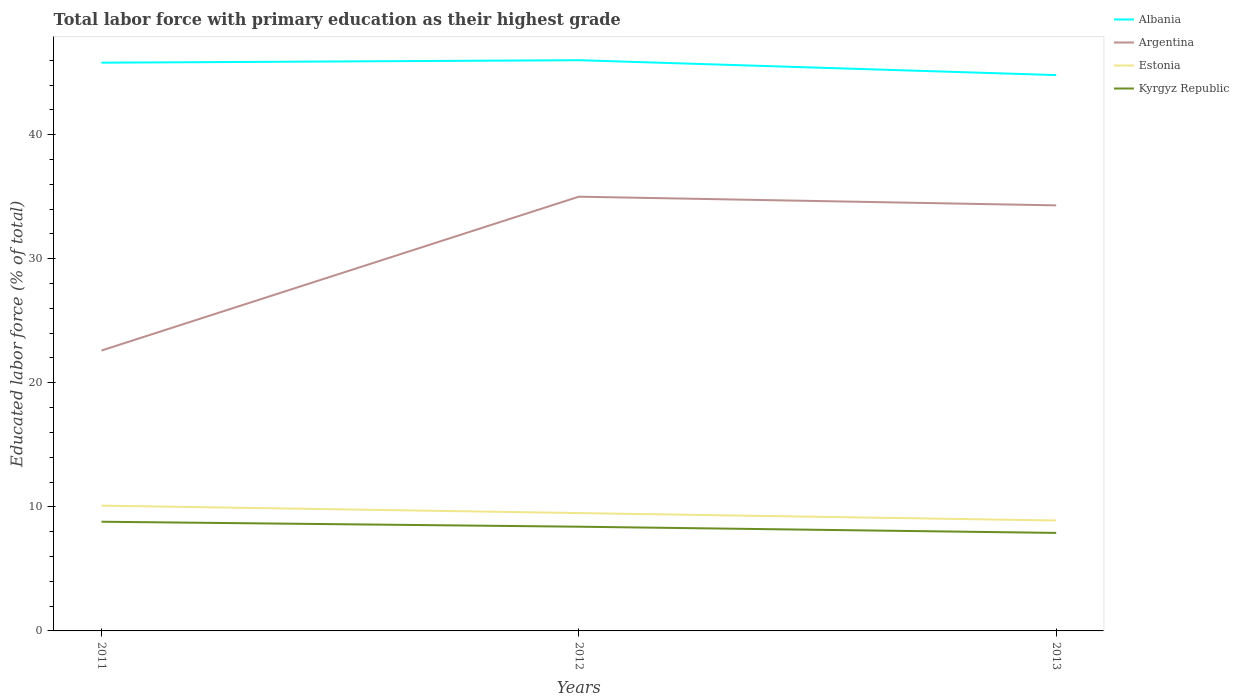Does the line corresponding to Kyrgyz Republic intersect with the line corresponding to Albania?
Keep it short and to the point. No. Is the number of lines equal to the number of legend labels?
Ensure brevity in your answer.  Yes. Across all years, what is the maximum percentage of total labor force with primary education in Albania?
Your answer should be very brief. 44.8. What is the total percentage of total labor force with primary education in Estonia in the graph?
Keep it short and to the point. 1.2. What is the difference between the highest and the second highest percentage of total labor force with primary education in Argentina?
Offer a terse response. 12.4. Is the percentage of total labor force with primary education in Kyrgyz Republic strictly greater than the percentage of total labor force with primary education in Estonia over the years?
Ensure brevity in your answer.  Yes. How many years are there in the graph?
Your answer should be compact. 3. What is the difference between two consecutive major ticks on the Y-axis?
Provide a succinct answer. 10. Are the values on the major ticks of Y-axis written in scientific E-notation?
Your answer should be very brief. No. Does the graph contain grids?
Your answer should be compact. No. How are the legend labels stacked?
Provide a short and direct response. Vertical. What is the title of the graph?
Your answer should be very brief. Total labor force with primary education as their highest grade. What is the label or title of the Y-axis?
Offer a terse response. Educated labor force (% of total). What is the Educated labor force (% of total) in Albania in 2011?
Your answer should be very brief. 45.8. What is the Educated labor force (% of total) in Argentina in 2011?
Ensure brevity in your answer.  22.6. What is the Educated labor force (% of total) in Estonia in 2011?
Provide a short and direct response. 10.1. What is the Educated labor force (% of total) of Kyrgyz Republic in 2011?
Your response must be concise. 8.8. What is the Educated labor force (% of total) of Albania in 2012?
Keep it short and to the point. 46. What is the Educated labor force (% of total) in Argentina in 2012?
Ensure brevity in your answer.  35. What is the Educated labor force (% of total) in Kyrgyz Republic in 2012?
Provide a short and direct response. 8.4. What is the Educated labor force (% of total) of Albania in 2013?
Give a very brief answer. 44.8. What is the Educated labor force (% of total) in Argentina in 2013?
Offer a very short reply. 34.3. What is the Educated labor force (% of total) of Estonia in 2013?
Offer a very short reply. 8.9. What is the Educated labor force (% of total) in Kyrgyz Republic in 2013?
Ensure brevity in your answer.  7.9. Across all years, what is the maximum Educated labor force (% of total) of Albania?
Make the answer very short. 46. Across all years, what is the maximum Educated labor force (% of total) of Argentina?
Your response must be concise. 35. Across all years, what is the maximum Educated labor force (% of total) in Estonia?
Keep it short and to the point. 10.1. Across all years, what is the maximum Educated labor force (% of total) of Kyrgyz Republic?
Your answer should be very brief. 8.8. Across all years, what is the minimum Educated labor force (% of total) of Albania?
Give a very brief answer. 44.8. Across all years, what is the minimum Educated labor force (% of total) of Argentina?
Provide a succinct answer. 22.6. Across all years, what is the minimum Educated labor force (% of total) of Estonia?
Your response must be concise. 8.9. Across all years, what is the minimum Educated labor force (% of total) of Kyrgyz Republic?
Make the answer very short. 7.9. What is the total Educated labor force (% of total) of Albania in the graph?
Provide a short and direct response. 136.6. What is the total Educated labor force (% of total) in Argentina in the graph?
Ensure brevity in your answer.  91.9. What is the total Educated labor force (% of total) of Estonia in the graph?
Provide a short and direct response. 28.5. What is the total Educated labor force (% of total) of Kyrgyz Republic in the graph?
Give a very brief answer. 25.1. What is the difference between the Educated labor force (% of total) of Albania in 2011 and that in 2012?
Your answer should be compact. -0.2. What is the difference between the Educated labor force (% of total) in Argentina in 2011 and that in 2012?
Offer a terse response. -12.4. What is the difference between the Educated labor force (% of total) in Estonia in 2011 and that in 2012?
Your answer should be compact. 0.6. What is the difference between the Educated labor force (% of total) of Estonia in 2011 and that in 2013?
Ensure brevity in your answer.  1.2. What is the difference between the Educated labor force (% of total) of Kyrgyz Republic in 2011 and that in 2013?
Offer a terse response. 0.9. What is the difference between the Educated labor force (% of total) in Argentina in 2012 and that in 2013?
Make the answer very short. 0.7. What is the difference between the Educated labor force (% of total) in Estonia in 2012 and that in 2013?
Keep it short and to the point. 0.6. What is the difference between the Educated labor force (% of total) of Kyrgyz Republic in 2012 and that in 2013?
Give a very brief answer. 0.5. What is the difference between the Educated labor force (% of total) of Albania in 2011 and the Educated labor force (% of total) of Estonia in 2012?
Make the answer very short. 36.3. What is the difference between the Educated labor force (% of total) in Albania in 2011 and the Educated labor force (% of total) in Kyrgyz Republic in 2012?
Offer a terse response. 37.4. What is the difference between the Educated labor force (% of total) in Argentina in 2011 and the Educated labor force (% of total) in Kyrgyz Republic in 2012?
Ensure brevity in your answer.  14.2. What is the difference between the Educated labor force (% of total) of Albania in 2011 and the Educated labor force (% of total) of Estonia in 2013?
Offer a very short reply. 36.9. What is the difference between the Educated labor force (% of total) in Albania in 2011 and the Educated labor force (% of total) in Kyrgyz Republic in 2013?
Offer a terse response. 37.9. What is the difference between the Educated labor force (% of total) of Argentina in 2011 and the Educated labor force (% of total) of Estonia in 2013?
Provide a short and direct response. 13.7. What is the difference between the Educated labor force (% of total) of Albania in 2012 and the Educated labor force (% of total) of Argentina in 2013?
Your answer should be compact. 11.7. What is the difference between the Educated labor force (% of total) of Albania in 2012 and the Educated labor force (% of total) of Estonia in 2013?
Ensure brevity in your answer.  37.1. What is the difference between the Educated labor force (% of total) of Albania in 2012 and the Educated labor force (% of total) of Kyrgyz Republic in 2013?
Your answer should be compact. 38.1. What is the difference between the Educated labor force (% of total) of Argentina in 2012 and the Educated labor force (% of total) of Estonia in 2013?
Keep it short and to the point. 26.1. What is the difference between the Educated labor force (% of total) in Argentina in 2012 and the Educated labor force (% of total) in Kyrgyz Republic in 2013?
Give a very brief answer. 27.1. What is the average Educated labor force (% of total) of Albania per year?
Offer a very short reply. 45.53. What is the average Educated labor force (% of total) of Argentina per year?
Keep it short and to the point. 30.63. What is the average Educated labor force (% of total) of Kyrgyz Republic per year?
Your answer should be very brief. 8.37. In the year 2011, what is the difference between the Educated labor force (% of total) in Albania and Educated labor force (% of total) in Argentina?
Your response must be concise. 23.2. In the year 2011, what is the difference between the Educated labor force (% of total) of Albania and Educated labor force (% of total) of Estonia?
Provide a short and direct response. 35.7. In the year 2011, what is the difference between the Educated labor force (% of total) of Albania and Educated labor force (% of total) of Kyrgyz Republic?
Give a very brief answer. 37. In the year 2011, what is the difference between the Educated labor force (% of total) in Argentina and Educated labor force (% of total) in Estonia?
Offer a terse response. 12.5. In the year 2011, what is the difference between the Educated labor force (% of total) in Argentina and Educated labor force (% of total) in Kyrgyz Republic?
Give a very brief answer. 13.8. In the year 2012, what is the difference between the Educated labor force (% of total) of Albania and Educated labor force (% of total) of Estonia?
Offer a very short reply. 36.5. In the year 2012, what is the difference between the Educated labor force (% of total) in Albania and Educated labor force (% of total) in Kyrgyz Republic?
Your answer should be compact. 37.6. In the year 2012, what is the difference between the Educated labor force (% of total) in Argentina and Educated labor force (% of total) in Kyrgyz Republic?
Your answer should be compact. 26.6. In the year 2013, what is the difference between the Educated labor force (% of total) in Albania and Educated labor force (% of total) in Argentina?
Ensure brevity in your answer.  10.5. In the year 2013, what is the difference between the Educated labor force (% of total) in Albania and Educated labor force (% of total) in Estonia?
Offer a terse response. 35.9. In the year 2013, what is the difference between the Educated labor force (% of total) of Albania and Educated labor force (% of total) of Kyrgyz Republic?
Provide a short and direct response. 36.9. In the year 2013, what is the difference between the Educated labor force (% of total) of Argentina and Educated labor force (% of total) of Estonia?
Your response must be concise. 25.4. In the year 2013, what is the difference between the Educated labor force (% of total) in Argentina and Educated labor force (% of total) in Kyrgyz Republic?
Provide a succinct answer. 26.4. What is the ratio of the Educated labor force (% of total) of Albania in 2011 to that in 2012?
Your response must be concise. 1. What is the ratio of the Educated labor force (% of total) in Argentina in 2011 to that in 2012?
Your answer should be very brief. 0.65. What is the ratio of the Educated labor force (% of total) in Estonia in 2011 to that in 2012?
Provide a succinct answer. 1.06. What is the ratio of the Educated labor force (% of total) of Kyrgyz Republic in 2011 to that in 2012?
Offer a terse response. 1.05. What is the ratio of the Educated labor force (% of total) of Albania in 2011 to that in 2013?
Give a very brief answer. 1.02. What is the ratio of the Educated labor force (% of total) in Argentina in 2011 to that in 2013?
Your response must be concise. 0.66. What is the ratio of the Educated labor force (% of total) in Estonia in 2011 to that in 2013?
Your response must be concise. 1.13. What is the ratio of the Educated labor force (% of total) in Kyrgyz Republic in 2011 to that in 2013?
Your answer should be very brief. 1.11. What is the ratio of the Educated labor force (% of total) of Albania in 2012 to that in 2013?
Make the answer very short. 1.03. What is the ratio of the Educated labor force (% of total) in Argentina in 2012 to that in 2013?
Your answer should be compact. 1.02. What is the ratio of the Educated labor force (% of total) in Estonia in 2012 to that in 2013?
Ensure brevity in your answer.  1.07. What is the ratio of the Educated labor force (% of total) of Kyrgyz Republic in 2012 to that in 2013?
Keep it short and to the point. 1.06. What is the difference between the highest and the second highest Educated labor force (% of total) of Albania?
Offer a very short reply. 0.2. What is the difference between the highest and the second highest Educated labor force (% of total) of Argentina?
Provide a succinct answer. 0.7. What is the difference between the highest and the second highest Educated labor force (% of total) of Kyrgyz Republic?
Ensure brevity in your answer.  0.4. What is the difference between the highest and the lowest Educated labor force (% of total) of Albania?
Your answer should be compact. 1.2. What is the difference between the highest and the lowest Educated labor force (% of total) of Estonia?
Make the answer very short. 1.2. What is the difference between the highest and the lowest Educated labor force (% of total) in Kyrgyz Republic?
Offer a terse response. 0.9. 